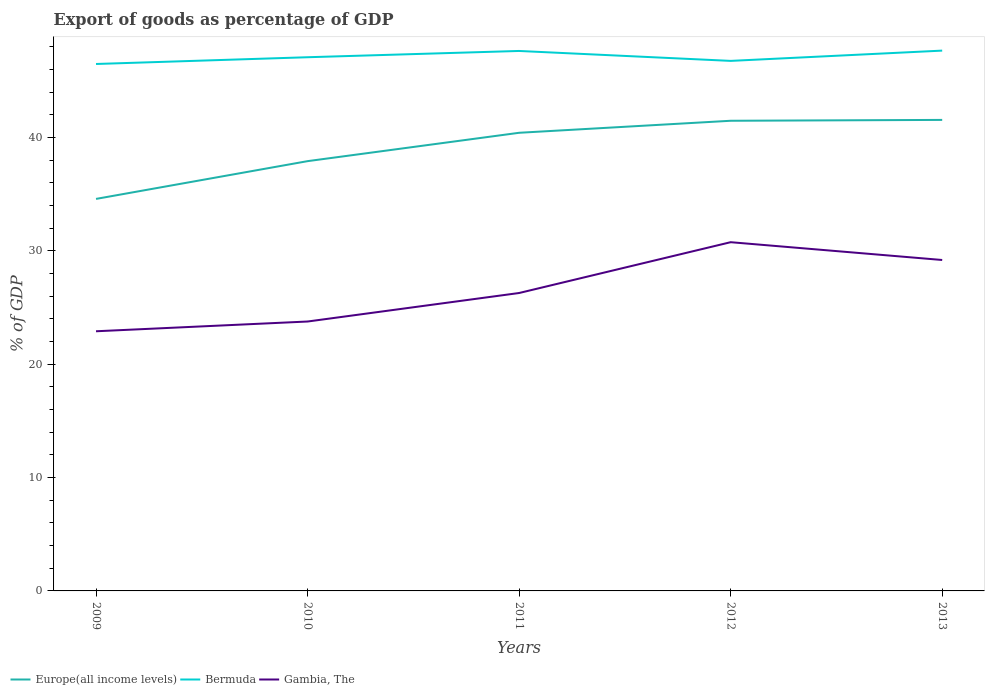How many different coloured lines are there?
Offer a terse response. 3. Does the line corresponding to Bermuda intersect with the line corresponding to Gambia, The?
Provide a short and direct response. No. Across all years, what is the maximum export of goods as percentage of GDP in Europe(all income levels)?
Offer a terse response. 34.59. In which year was the export of goods as percentage of GDP in Bermuda maximum?
Provide a succinct answer. 2009. What is the total export of goods as percentage of GDP in Europe(all income levels) in the graph?
Your answer should be compact. -1.14. What is the difference between the highest and the second highest export of goods as percentage of GDP in Gambia, The?
Give a very brief answer. 7.86. Is the export of goods as percentage of GDP in Bermuda strictly greater than the export of goods as percentage of GDP in Gambia, The over the years?
Give a very brief answer. No. Does the graph contain any zero values?
Give a very brief answer. No. Does the graph contain grids?
Your answer should be compact. No. Where does the legend appear in the graph?
Your answer should be compact. Bottom left. How many legend labels are there?
Your response must be concise. 3. What is the title of the graph?
Give a very brief answer. Export of goods as percentage of GDP. What is the label or title of the Y-axis?
Give a very brief answer. % of GDP. What is the % of GDP of Europe(all income levels) in 2009?
Offer a terse response. 34.59. What is the % of GDP of Bermuda in 2009?
Provide a succinct answer. 46.49. What is the % of GDP of Gambia, The in 2009?
Offer a very short reply. 22.91. What is the % of GDP of Europe(all income levels) in 2010?
Your answer should be compact. 37.92. What is the % of GDP in Bermuda in 2010?
Provide a succinct answer. 47.08. What is the % of GDP of Gambia, The in 2010?
Provide a short and direct response. 23.77. What is the % of GDP in Europe(all income levels) in 2011?
Your response must be concise. 40.42. What is the % of GDP of Bermuda in 2011?
Provide a short and direct response. 47.64. What is the % of GDP in Gambia, The in 2011?
Make the answer very short. 26.28. What is the % of GDP of Europe(all income levels) in 2012?
Your response must be concise. 41.48. What is the % of GDP in Bermuda in 2012?
Your response must be concise. 46.76. What is the % of GDP of Gambia, The in 2012?
Give a very brief answer. 30.77. What is the % of GDP in Europe(all income levels) in 2013?
Provide a succinct answer. 41.55. What is the % of GDP in Bermuda in 2013?
Provide a short and direct response. 47.67. What is the % of GDP in Gambia, The in 2013?
Ensure brevity in your answer.  29.2. Across all years, what is the maximum % of GDP in Europe(all income levels)?
Provide a succinct answer. 41.55. Across all years, what is the maximum % of GDP in Bermuda?
Your response must be concise. 47.67. Across all years, what is the maximum % of GDP in Gambia, The?
Your answer should be very brief. 30.77. Across all years, what is the minimum % of GDP in Europe(all income levels)?
Ensure brevity in your answer.  34.59. Across all years, what is the minimum % of GDP in Bermuda?
Give a very brief answer. 46.49. Across all years, what is the minimum % of GDP of Gambia, The?
Offer a terse response. 22.91. What is the total % of GDP in Europe(all income levels) in the graph?
Provide a short and direct response. 195.95. What is the total % of GDP of Bermuda in the graph?
Offer a very short reply. 235.64. What is the total % of GDP of Gambia, The in the graph?
Make the answer very short. 132.92. What is the difference between the % of GDP in Europe(all income levels) in 2009 and that in 2010?
Provide a succinct answer. -3.33. What is the difference between the % of GDP in Bermuda in 2009 and that in 2010?
Keep it short and to the point. -0.59. What is the difference between the % of GDP of Gambia, The in 2009 and that in 2010?
Provide a short and direct response. -0.86. What is the difference between the % of GDP in Europe(all income levels) in 2009 and that in 2011?
Ensure brevity in your answer.  -5.83. What is the difference between the % of GDP of Bermuda in 2009 and that in 2011?
Keep it short and to the point. -1.15. What is the difference between the % of GDP in Gambia, The in 2009 and that in 2011?
Keep it short and to the point. -3.38. What is the difference between the % of GDP of Europe(all income levels) in 2009 and that in 2012?
Provide a short and direct response. -6.89. What is the difference between the % of GDP of Bermuda in 2009 and that in 2012?
Make the answer very short. -0.27. What is the difference between the % of GDP of Gambia, The in 2009 and that in 2012?
Ensure brevity in your answer.  -7.86. What is the difference between the % of GDP of Europe(all income levels) in 2009 and that in 2013?
Your answer should be compact. -6.97. What is the difference between the % of GDP of Bermuda in 2009 and that in 2013?
Your answer should be very brief. -1.18. What is the difference between the % of GDP of Gambia, The in 2009 and that in 2013?
Make the answer very short. -6.29. What is the difference between the % of GDP in Europe(all income levels) in 2010 and that in 2011?
Your answer should be very brief. -2.5. What is the difference between the % of GDP of Bermuda in 2010 and that in 2011?
Your answer should be compact. -0.55. What is the difference between the % of GDP of Gambia, The in 2010 and that in 2011?
Make the answer very short. -2.52. What is the difference between the % of GDP in Europe(all income levels) in 2010 and that in 2012?
Provide a short and direct response. -3.56. What is the difference between the % of GDP in Bermuda in 2010 and that in 2012?
Your answer should be compact. 0.32. What is the difference between the % of GDP of Gambia, The in 2010 and that in 2012?
Give a very brief answer. -7. What is the difference between the % of GDP of Europe(all income levels) in 2010 and that in 2013?
Provide a succinct answer. -3.64. What is the difference between the % of GDP in Bermuda in 2010 and that in 2013?
Provide a succinct answer. -0.59. What is the difference between the % of GDP of Gambia, The in 2010 and that in 2013?
Provide a succinct answer. -5.43. What is the difference between the % of GDP in Europe(all income levels) in 2011 and that in 2012?
Your answer should be compact. -1.06. What is the difference between the % of GDP of Bermuda in 2011 and that in 2012?
Make the answer very short. 0.88. What is the difference between the % of GDP of Gambia, The in 2011 and that in 2012?
Give a very brief answer. -4.48. What is the difference between the % of GDP in Europe(all income levels) in 2011 and that in 2013?
Your response must be concise. -1.14. What is the difference between the % of GDP of Bermuda in 2011 and that in 2013?
Give a very brief answer. -0.03. What is the difference between the % of GDP of Gambia, The in 2011 and that in 2013?
Your answer should be compact. -2.91. What is the difference between the % of GDP of Europe(all income levels) in 2012 and that in 2013?
Offer a terse response. -0.08. What is the difference between the % of GDP of Bermuda in 2012 and that in 2013?
Your response must be concise. -0.91. What is the difference between the % of GDP of Gambia, The in 2012 and that in 2013?
Your response must be concise. 1.57. What is the difference between the % of GDP in Europe(all income levels) in 2009 and the % of GDP in Bermuda in 2010?
Provide a succinct answer. -12.5. What is the difference between the % of GDP in Europe(all income levels) in 2009 and the % of GDP in Gambia, The in 2010?
Your answer should be compact. 10.82. What is the difference between the % of GDP in Bermuda in 2009 and the % of GDP in Gambia, The in 2010?
Keep it short and to the point. 22.72. What is the difference between the % of GDP of Europe(all income levels) in 2009 and the % of GDP of Bermuda in 2011?
Make the answer very short. -13.05. What is the difference between the % of GDP in Europe(all income levels) in 2009 and the % of GDP in Gambia, The in 2011?
Ensure brevity in your answer.  8.3. What is the difference between the % of GDP of Bermuda in 2009 and the % of GDP of Gambia, The in 2011?
Make the answer very short. 20.21. What is the difference between the % of GDP of Europe(all income levels) in 2009 and the % of GDP of Bermuda in 2012?
Your answer should be very brief. -12.18. What is the difference between the % of GDP in Europe(all income levels) in 2009 and the % of GDP in Gambia, The in 2012?
Provide a succinct answer. 3.82. What is the difference between the % of GDP in Bermuda in 2009 and the % of GDP in Gambia, The in 2012?
Your answer should be compact. 15.72. What is the difference between the % of GDP of Europe(all income levels) in 2009 and the % of GDP of Bermuda in 2013?
Provide a short and direct response. -13.08. What is the difference between the % of GDP in Europe(all income levels) in 2009 and the % of GDP in Gambia, The in 2013?
Make the answer very short. 5.39. What is the difference between the % of GDP in Bermuda in 2009 and the % of GDP in Gambia, The in 2013?
Your answer should be very brief. 17.29. What is the difference between the % of GDP in Europe(all income levels) in 2010 and the % of GDP in Bermuda in 2011?
Your response must be concise. -9.72. What is the difference between the % of GDP of Europe(all income levels) in 2010 and the % of GDP of Gambia, The in 2011?
Offer a terse response. 11.63. What is the difference between the % of GDP of Bermuda in 2010 and the % of GDP of Gambia, The in 2011?
Keep it short and to the point. 20.8. What is the difference between the % of GDP in Europe(all income levels) in 2010 and the % of GDP in Bermuda in 2012?
Ensure brevity in your answer.  -8.85. What is the difference between the % of GDP in Europe(all income levels) in 2010 and the % of GDP in Gambia, The in 2012?
Offer a terse response. 7.15. What is the difference between the % of GDP in Bermuda in 2010 and the % of GDP in Gambia, The in 2012?
Provide a succinct answer. 16.32. What is the difference between the % of GDP of Europe(all income levels) in 2010 and the % of GDP of Bermuda in 2013?
Ensure brevity in your answer.  -9.75. What is the difference between the % of GDP of Europe(all income levels) in 2010 and the % of GDP of Gambia, The in 2013?
Give a very brief answer. 8.72. What is the difference between the % of GDP in Bermuda in 2010 and the % of GDP in Gambia, The in 2013?
Offer a very short reply. 17.89. What is the difference between the % of GDP of Europe(all income levels) in 2011 and the % of GDP of Bermuda in 2012?
Keep it short and to the point. -6.34. What is the difference between the % of GDP of Europe(all income levels) in 2011 and the % of GDP of Gambia, The in 2012?
Ensure brevity in your answer.  9.65. What is the difference between the % of GDP of Bermuda in 2011 and the % of GDP of Gambia, The in 2012?
Keep it short and to the point. 16.87. What is the difference between the % of GDP of Europe(all income levels) in 2011 and the % of GDP of Bermuda in 2013?
Your answer should be very brief. -7.25. What is the difference between the % of GDP of Europe(all income levels) in 2011 and the % of GDP of Gambia, The in 2013?
Your response must be concise. 11.22. What is the difference between the % of GDP of Bermuda in 2011 and the % of GDP of Gambia, The in 2013?
Make the answer very short. 18.44. What is the difference between the % of GDP in Europe(all income levels) in 2012 and the % of GDP in Bermuda in 2013?
Offer a terse response. -6.19. What is the difference between the % of GDP in Europe(all income levels) in 2012 and the % of GDP in Gambia, The in 2013?
Provide a succinct answer. 12.28. What is the difference between the % of GDP in Bermuda in 2012 and the % of GDP in Gambia, The in 2013?
Your answer should be very brief. 17.57. What is the average % of GDP in Europe(all income levels) per year?
Provide a succinct answer. 39.19. What is the average % of GDP of Bermuda per year?
Give a very brief answer. 47.13. What is the average % of GDP in Gambia, The per year?
Your answer should be compact. 26.58. In the year 2009, what is the difference between the % of GDP of Europe(all income levels) and % of GDP of Bermuda?
Your answer should be compact. -11.9. In the year 2009, what is the difference between the % of GDP of Europe(all income levels) and % of GDP of Gambia, The?
Offer a very short reply. 11.68. In the year 2009, what is the difference between the % of GDP of Bermuda and % of GDP of Gambia, The?
Your response must be concise. 23.58. In the year 2010, what is the difference between the % of GDP in Europe(all income levels) and % of GDP in Bermuda?
Your response must be concise. -9.17. In the year 2010, what is the difference between the % of GDP in Europe(all income levels) and % of GDP in Gambia, The?
Your response must be concise. 14.15. In the year 2010, what is the difference between the % of GDP in Bermuda and % of GDP in Gambia, The?
Keep it short and to the point. 23.32. In the year 2011, what is the difference between the % of GDP of Europe(all income levels) and % of GDP of Bermuda?
Provide a short and direct response. -7.22. In the year 2011, what is the difference between the % of GDP in Europe(all income levels) and % of GDP in Gambia, The?
Provide a succinct answer. 14.14. In the year 2011, what is the difference between the % of GDP in Bermuda and % of GDP in Gambia, The?
Provide a succinct answer. 21.35. In the year 2012, what is the difference between the % of GDP of Europe(all income levels) and % of GDP of Bermuda?
Provide a succinct answer. -5.28. In the year 2012, what is the difference between the % of GDP of Europe(all income levels) and % of GDP of Gambia, The?
Offer a very short reply. 10.71. In the year 2012, what is the difference between the % of GDP in Bermuda and % of GDP in Gambia, The?
Offer a terse response. 16. In the year 2013, what is the difference between the % of GDP in Europe(all income levels) and % of GDP in Bermuda?
Make the answer very short. -6.11. In the year 2013, what is the difference between the % of GDP in Europe(all income levels) and % of GDP in Gambia, The?
Make the answer very short. 12.36. In the year 2013, what is the difference between the % of GDP in Bermuda and % of GDP in Gambia, The?
Give a very brief answer. 18.47. What is the ratio of the % of GDP in Europe(all income levels) in 2009 to that in 2010?
Provide a short and direct response. 0.91. What is the ratio of the % of GDP in Bermuda in 2009 to that in 2010?
Give a very brief answer. 0.99. What is the ratio of the % of GDP of Gambia, The in 2009 to that in 2010?
Keep it short and to the point. 0.96. What is the ratio of the % of GDP of Europe(all income levels) in 2009 to that in 2011?
Offer a very short reply. 0.86. What is the ratio of the % of GDP in Bermuda in 2009 to that in 2011?
Your answer should be very brief. 0.98. What is the ratio of the % of GDP of Gambia, The in 2009 to that in 2011?
Ensure brevity in your answer.  0.87. What is the ratio of the % of GDP of Europe(all income levels) in 2009 to that in 2012?
Offer a terse response. 0.83. What is the ratio of the % of GDP in Gambia, The in 2009 to that in 2012?
Provide a succinct answer. 0.74. What is the ratio of the % of GDP of Europe(all income levels) in 2009 to that in 2013?
Make the answer very short. 0.83. What is the ratio of the % of GDP in Bermuda in 2009 to that in 2013?
Make the answer very short. 0.98. What is the ratio of the % of GDP of Gambia, The in 2009 to that in 2013?
Your answer should be compact. 0.78. What is the ratio of the % of GDP in Europe(all income levels) in 2010 to that in 2011?
Your answer should be very brief. 0.94. What is the ratio of the % of GDP of Bermuda in 2010 to that in 2011?
Your response must be concise. 0.99. What is the ratio of the % of GDP of Gambia, The in 2010 to that in 2011?
Keep it short and to the point. 0.9. What is the ratio of the % of GDP of Europe(all income levels) in 2010 to that in 2012?
Give a very brief answer. 0.91. What is the ratio of the % of GDP in Gambia, The in 2010 to that in 2012?
Provide a succinct answer. 0.77. What is the ratio of the % of GDP of Europe(all income levels) in 2010 to that in 2013?
Provide a succinct answer. 0.91. What is the ratio of the % of GDP in Gambia, The in 2010 to that in 2013?
Ensure brevity in your answer.  0.81. What is the ratio of the % of GDP in Europe(all income levels) in 2011 to that in 2012?
Give a very brief answer. 0.97. What is the ratio of the % of GDP of Bermuda in 2011 to that in 2012?
Make the answer very short. 1.02. What is the ratio of the % of GDP of Gambia, The in 2011 to that in 2012?
Make the answer very short. 0.85. What is the ratio of the % of GDP in Europe(all income levels) in 2011 to that in 2013?
Offer a very short reply. 0.97. What is the ratio of the % of GDP in Gambia, The in 2011 to that in 2013?
Keep it short and to the point. 0.9. What is the ratio of the % of GDP of Gambia, The in 2012 to that in 2013?
Provide a short and direct response. 1.05. What is the difference between the highest and the second highest % of GDP in Europe(all income levels)?
Keep it short and to the point. 0.08. What is the difference between the highest and the second highest % of GDP of Bermuda?
Keep it short and to the point. 0.03. What is the difference between the highest and the second highest % of GDP in Gambia, The?
Make the answer very short. 1.57. What is the difference between the highest and the lowest % of GDP in Europe(all income levels)?
Give a very brief answer. 6.97. What is the difference between the highest and the lowest % of GDP of Bermuda?
Provide a succinct answer. 1.18. What is the difference between the highest and the lowest % of GDP in Gambia, The?
Provide a succinct answer. 7.86. 